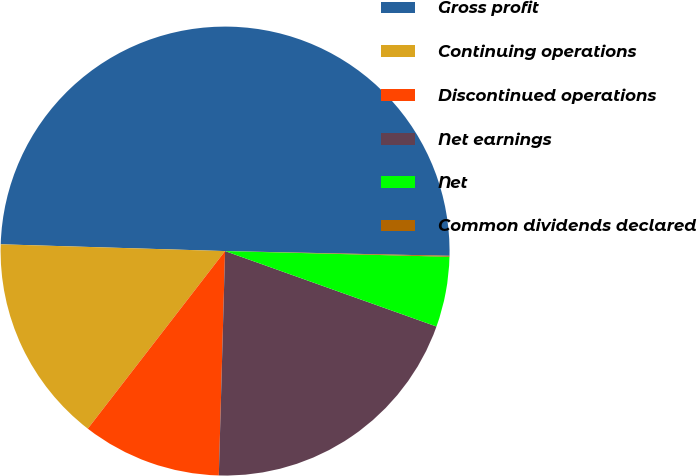<chart> <loc_0><loc_0><loc_500><loc_500><pie_chart><fcel>Gross profit<fcel>Continuing operations<fcel>Discontinued operations<fcel>Net earnings<fcel>Net<fcel>Common dividends declared<nl><fcel>49.86%<fcel>15.01%<fcel>10.03%<fcel>19.99%<fcel>5.05%<fcel>0.07%<nl></chart> 